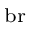<formula> <loc_0><loc_0><loc_500><loc_500>_ { b } r</formula> 